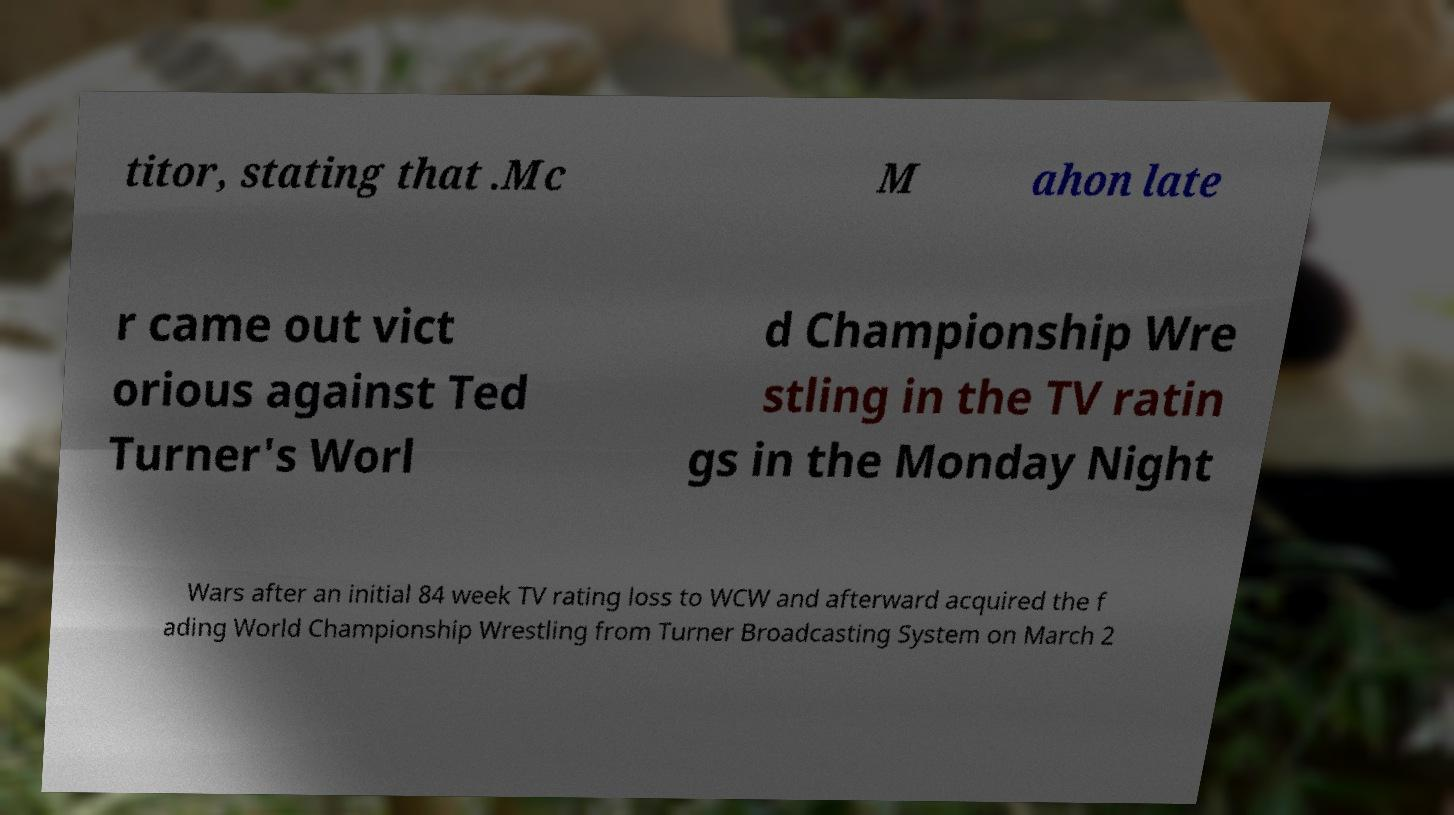Please identify and transcribe the text found in this image. titor, stating that .Mc M ahon late r came out vict orious against Ted Turner's Worl d Championship Wre stling in the TV ratin gs in the Monday Night Wars after an initial 84 week TV rating loss to WCW and afterward acquired the f ading World Championship Wrestling from Turner Broadcasting System on March 2 